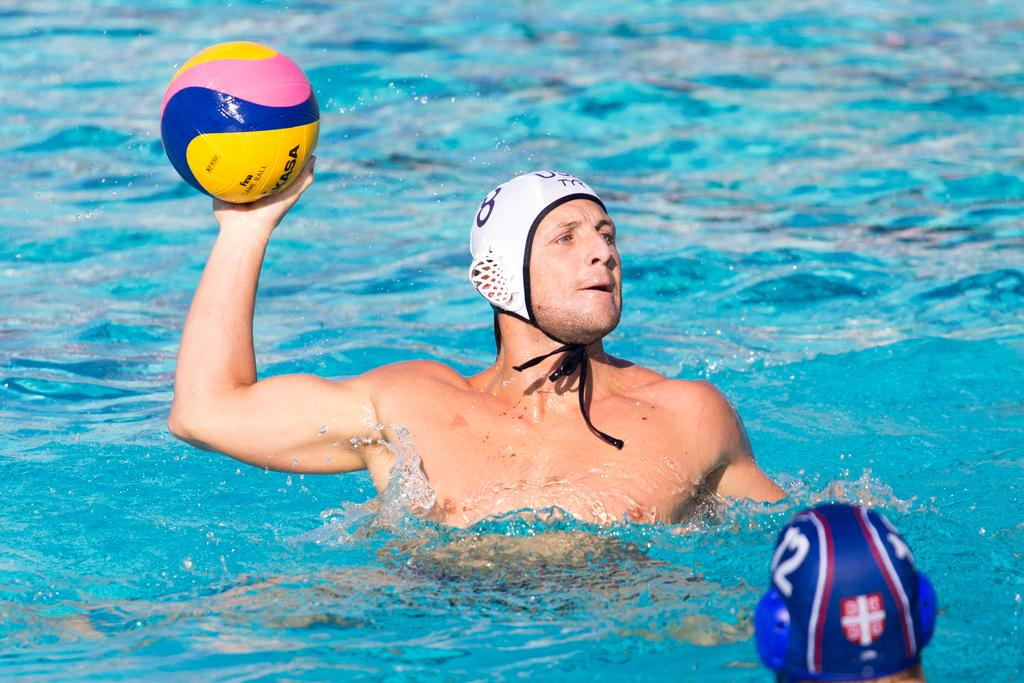How many people are in the image? There are two persons in the image. What is the setting or environment in which the two persons are located? The two persons are in water. What is one of the persons holding in the image? One person is holding a ball. What type of paste is visible on the head of one of the persons in the image? There is no paste visible on the head of any person in the image. What type of hat is one of the persons wearing in the image? There is no hat visible on the head of any person in the image. 